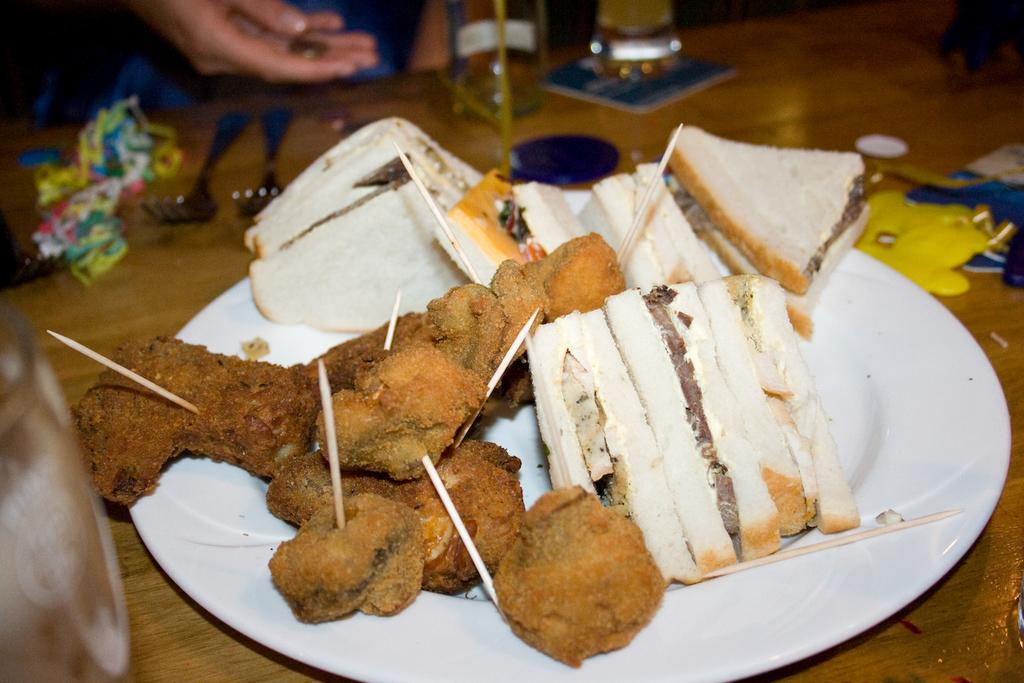What piece of furniture is present in the image? There is a table in the image. What items can be found on the table? There is cutlery, glass tumblers, paper napkins, and a serving plate on the table. What is the purpose of the serving plate? The serving plate contains food. What additional items are present in the serving plate? There are toothpicks in the serving plate. What type of collar can be seen on the toothpicks in the image? There is no collar present on the toothpicks in the image. How many rings are visible on the serving plate in the image? There are no rings visible on the serving plate in the image. --- Facts: 1. There is a person sitting on a chair in the image. 2. The person is holding a book. 3. The book has a red cover. 4. The person is wearing glasses. 5. There is a lamp on a table next to the chair. Absurd Topics: parrot, bicycle, ocean Conversation: What is the person in the image doing? The person is sitting on a chair in the image. What object is the person holding? The person is holding a book. What can be said about the book's appearance? The book has a red cover. What accessory is the person wearing? The person is wearing glasses. What is located next to the chair in the image? There is a lamp on a table next to the chair. Reasoning: Let's think step by step in order to produce the conversation. We start by identifying the main subject in the image, which is the person sitting on a chair. Then, we describe the object the person is holding, which is a book with a red cover. We also mention the person's accessory, which are glasses, and the additional item located next to the chair, which is a lamp on a table. Absurd Question/Answer: Can you see a parrot sitting on the person's shoulder in the image? No, there is no parrot present in the image. Is the person riding a bicycle in the image? No, the person is sitting on a chair, not riding a bicycle. 